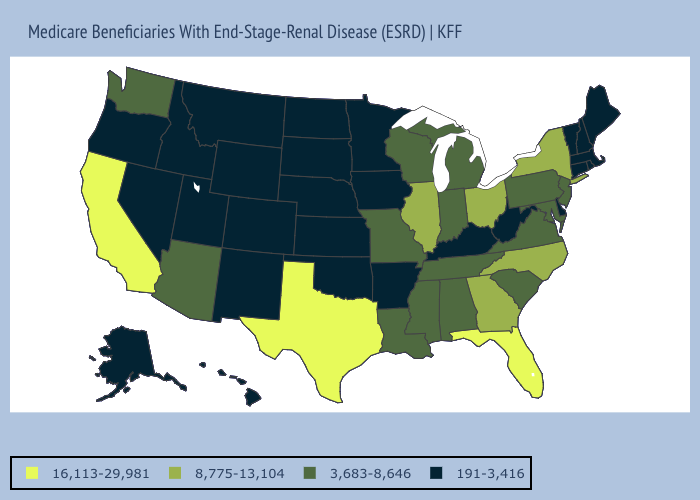Name the states that have a value in the range 16,113-29,981?
Quick response, please. California, Florida, Texas. Does West Virginia have a lower value than New Hampshire?
Write a very short answer. No. Does Idaho have the same value as New Mexico?
Concise answer only. Yes. Name the states that have a value in the range 8,775-13,104?
Be succinct. Georgia, Illinois, New York, North Carolina, Ohio. Does the map have missing data?
Concise answer only. No. Does Vermont have the lowest value in the Northeast?
Quick response, please. Yes. What is the value of Rhode Island?
Write a very short answer. 191-3,416. What is the value of Nevada?
Answer briefly. 191-3,416. Does Louisiana have the same value as Alaska?
Answer briefly. No. Name the states that have a value in the range 16,113-29,981?
Quick response, please. California, Florida, Texas. What is the value of Connecticut?
Give a very brief answer. 191-3,416. What is the value of Indiana?
Concise answer only. 3,683-8,646. Name the states that have a value in the range 16,113-29,981?
Keep it brief. California, Florida, Texas. Does Alaska have the same value as Indiana?
Give a very brief answer. No. What is the lowest value in the USA?
Concise answer only. 191-3,416. 